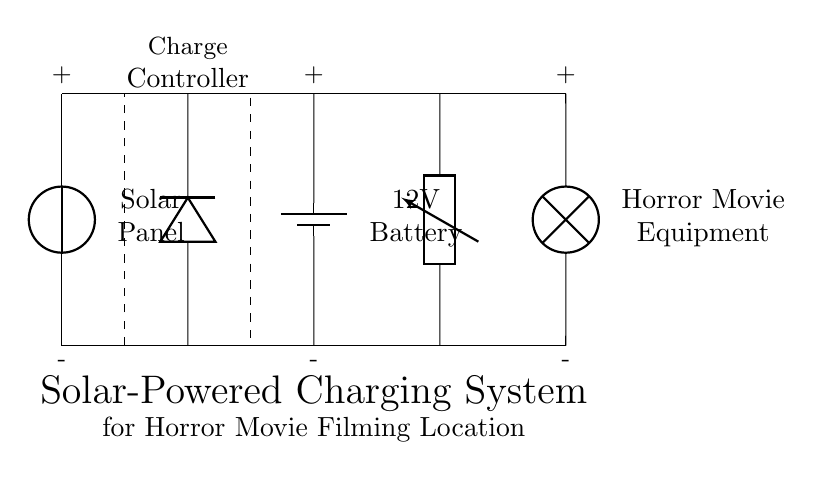What type of energy source is used in this system? The system utilizes solar energy as indicated by the solar panel component at the beginning of the circuit.
Answer: solar What component stores energy in this circuit? The battery is depicted as storing energy, where it is labeled as a 12V battery in the diagram.
Answer: 12V Battery How many components are involved in the charging system? The circuit includes five key components: the solar panel, charge controller, battery, DC-AC inverter, and the load (horror movie equipment).
Answer: five What is the role of the charge controller? The charge controller regulates the energy flow between the solar panel and the battery, preventing overcharging, as can be inferred from the dashed rectangle labeled "Charge Controller."
Answer: regulates How does the inverter affect the equipment? The inverter converts DC from the battery to AC, which powers the horror movie equipment labeled as "Lamp," allowing the use of standard electronics.
Answer: converts to AC What is the total voltage supplied by the battery? The battery provides a specified voltage of 12V, indicated directly next to the battery in the diagram, which is crucial for powering the connected equipment.
Answer: 12V What is the final destination of the electricity in this circuit? The electricity flows to the load, specifically the horror movie equipment, which is indicated at the end of the circuit connected to the inverter.
Answer: horror movie equipment 